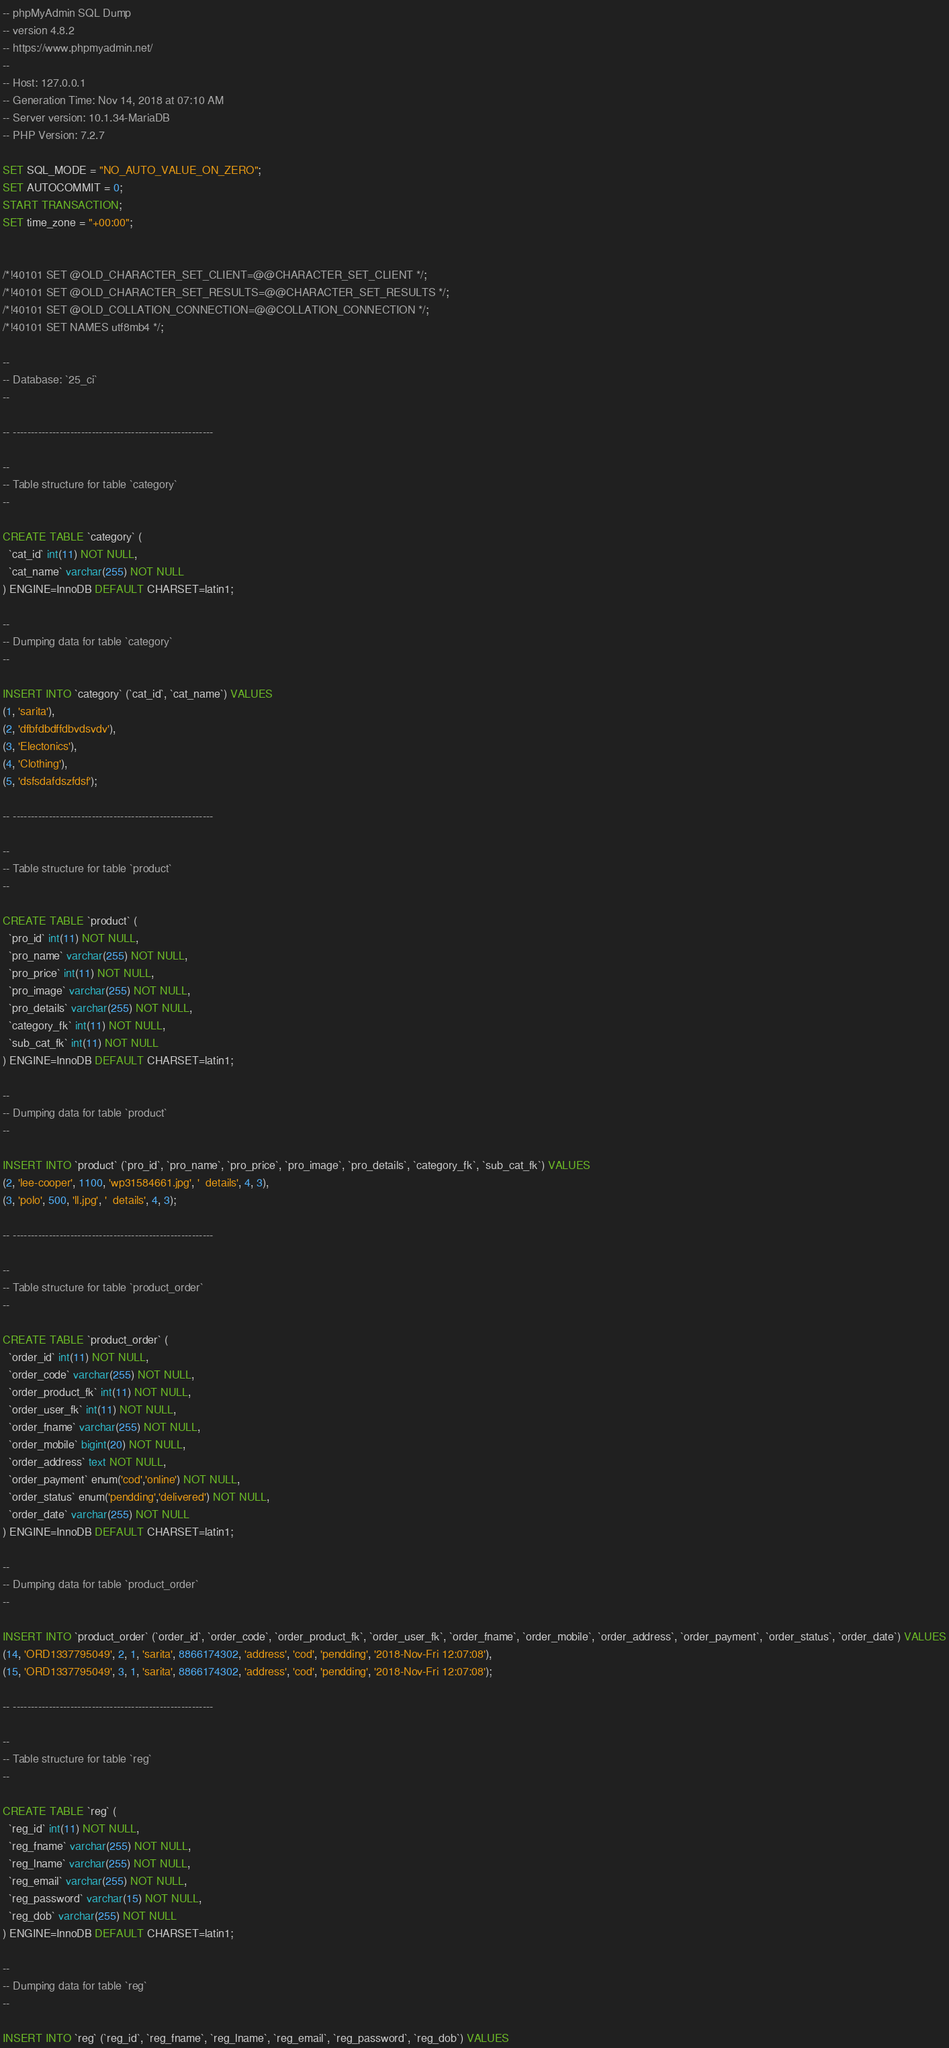<code> <loc_0><loc_0><loc_500><loc_500><_SQL_>-- phpMyAdmin SQL Dump
-- version 4.8.2
-- https://www.phpmyadmin.net/
--
-- Host: 127.0.0.1
-- Generation Time: Nov 14, 2018 at 07:10 AM
-- Server version: 10.1.34-MariaDB
-- PHP Version: 7.2.7

SET SQL_MODE = "NO_AUTO_VALUE_ON_ZERO";
SET AUTOCOMMIT = 0;
START TRANSACTION;
SET time_zone = "+00:00";


/*!40101 SET @OLD_CHARACTER_SET_CLIENT=@@CHARACTER_SET_CLIENT */;
/*!40101 SET @OLD_CHARACTER_SET_RESULTS=@@CHARACTER_SET_RESULTS */;
/*!40101 SET @OLD_COLLATION_CONNECTION=@@COLLATION_CONNECTION */;
/*!40101 SET NAMES utf8mb4 */;

--
-- Database: `25_ci`
--

-- --------------------------------------------------------

--
-- Table structure for table `category`
--

CREATE TABLE `category` (
  `cat_id` int(11) NOT NULL,
  `cat_name` varchar(255) NOT NULL
) ENGINE=InnoDB DEFAULT CHARSET=latin1;

--
-- Dumping data for table `category`
--

INSERT INTO `category` (`cat_id`, `cat_name`) VALUES
(1, 'sarita'),
(2, 'dfbfdbdffdbvdsvdv'),
(3, 'Electonics'),
(4, 'Clothing'),
(5, 'dsfsdafdszfdsf');

-- --------------------------------------------------------

--
-- Table structure for table `product`
--

CREATE TABLE `product` (
  `pro_id` int(11) NOT NULL,
  `pro_name` varchar(255) NOT NULL,
  `pro_price` int(11) NOT NULL,
  `pro_image` varchar(255) NOT NULL,
  `pro_details` varchar(255) NOT NULL,
  `category_fk` int(11) NOT NULL,
  `sub_cat_fk` int(11) NOT NULL
) ENGINE=InnoDB DEFAULT CHARSET=latin1;

--
-- Dumping data for table `product`
--

INSERT INTO `product` (`pro_id`, `pro_name`, `pro_price`, `pro_image`, `pro_details`, `category_fk`, `sub_cat_fk`) VALUES
(2, 'lee-cooper', 1100, 'wp31584661.jpg', '  details', 4, 3),
(3, 'polo', 500, 'll.jpg', '  details', 4, 3);

-- --------------------------------------------------------

--
-- Table structure for table `product_order`
--

CREATE TABLE `product_order` (
  `order_id` int(11) NOT NULL,
  `order_code` varchar(255) NOT NULL,
  `order_product_fk` int(11) NOT NULL,
  `order_user_fk` int(11) NOT NULL,
  `order_fname` varchar(255) NOT NULL,
  `order_mobile` bigint(20) NOT NULL,
  `order_address` text NOT NULL,
  `order_payment` enum('cod','online') NOT NULL,
  `order_status` enum('pendding','delivered') NOT NULL,
  `order_date` varchar(255) NOT NULL
) ENGINE=InnoDB DEFAULT CHARSET=latin1;

--
-- Dumping data for table `product_order`
--

INSERT INTO `product_order` (`order_id`, `order_code`, `order_product_fk`, `order_user_fk`, `order_fname`, `order_mobile`, `order_address`, `order_payment`, `order_status`, `order_date`) VALUES
(14, 'ORD1337795049', 2, 1, 'sarita', 8866174302, 'address', 'cod', 'pendding', '2018-Nov-Fri 12:07:08'),
(15, 'ORD1337795049', 3, 1, 'sarita', 8866174302, 'address', 'cod', 'pendding', '2018-Nov-Fri 12:07:08');

-- --------------------------------------------------------

--
-- Table structure for table `reg`
--

CREATE TABLE `reg` (
  `reg_id` int(11) NOT NULL,
  `reg_fname` varchar(255) NOT NULL,
  `reg_lname` varchar(255) NOT NULL,
  `reg_email` varchar(255) NOT NULL,
  `reg_password` varchar(15) NOT NULL,
  `reg_dob` varchar(255) NOT NULL
) ENGINE=InnoDB DEFAULT CHARSET=latin1;

--
-- Dumping data for table `reg`
--

INSERT INTO `reg` (`reg_id`, `reg_fname`, `reg_lname`, `reg_email`, `reg_password`, `reg_dob`) VALUES</code> 